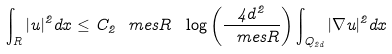Convert formula to latex. <formula><loc_0><loc_0><loc_500><loc_500>\int _ { R } | u | ^ { 2 } d x \leq C _ { 2 } \ m e s R \ \log \left ( \frac { 4 d ^ { 2 } } { \ m e s R } \right ) \int _ { Q _ { 2 d } } | \nabla u | ^ { 2 } d x</formula> 